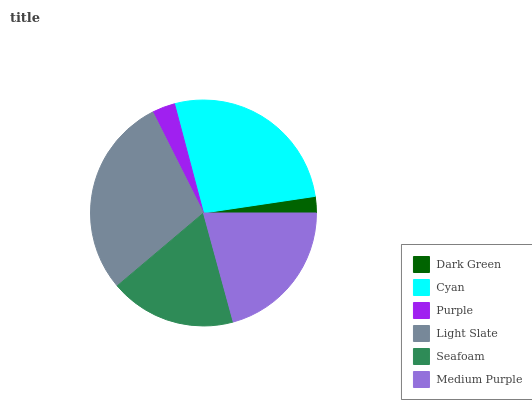Is Dark Green the minimum?
Answer yes or no. Yes. Is Light Slate the maximum?
Answer yes or no. Yes. Is Cyan the minimum?
Answer yes or no. No. Is Cyan the maximum?
Answer yes or no. No. Is Cyan greater than Dark Green?
Answer yes or no. Yes. Is Dark Green less than Cyan?
Answer yes or no. Yes. Is Dark Green greater than Cyan?
Answer yes or no. No. Is Cyan less than Dark Green?
Answer yes or no. No. Is Medium Purple the high median?
Answer yes or no. Yes. Is Seafoam the low median?
Answer yes or no. Yes. Is Light Slate the high median?
Answer yes or no. No. Is Cyan the low median?
Answer yes or no. No. 